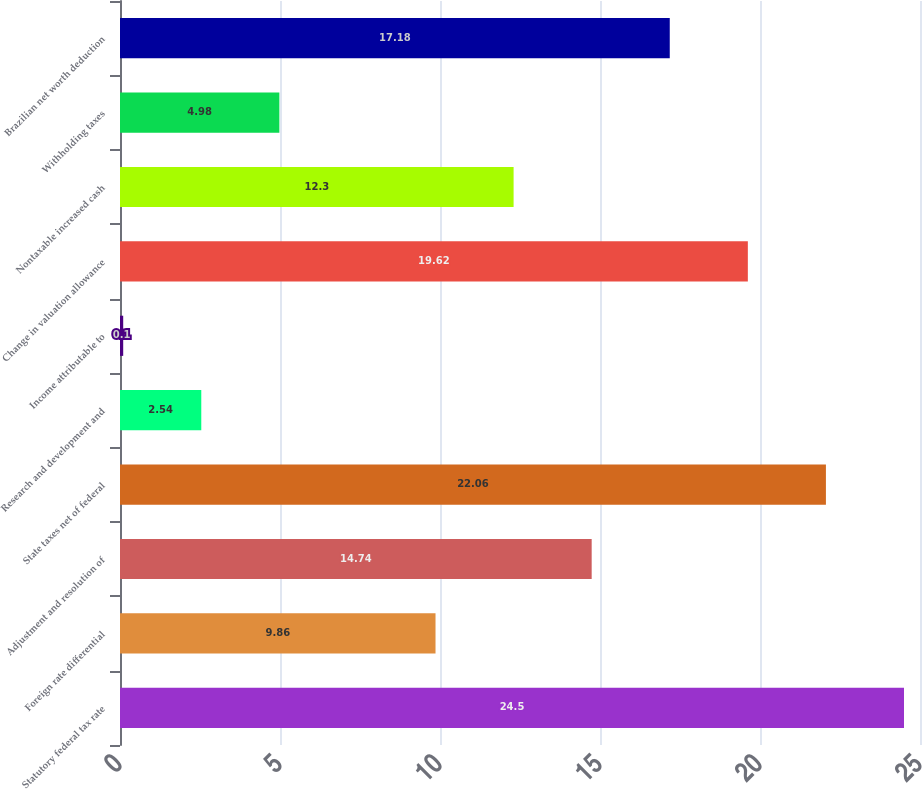<chart> <loc_0><loc_0><loc_500><loc_500><bar_chart><fcel>Statutory federal tax rate<fcel>Foreign rate differential<fcel>Adjustment and resolution of<fcel>State taxes net of federal<fcel>Research and development and<fcel>Income attributable to<fcel>Change in valuation allowance<fcel>Nontaxable increased cash<fcel>Withholding taxes<fcel>Brazilian net worth deduction<nl><fcel>24.5<fcel>9.86<fcel>14.74<fcel>22.06<fcel>2.54<fcel>0.1<fcel>19.62<fcel>12.3<fcel>4.98<fcel>17.18<nl></chart> 